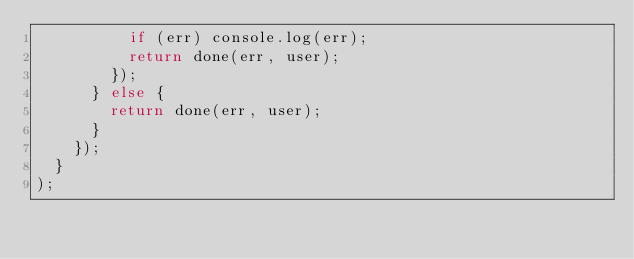<code> <loc_0><loc_0><loc_500><loc_500><_JavaScript_>          if (err) console.log(err);
          return done(err, user);
        });
      } else {
        return done(err, user);
      }
    });
  }
);
</code> 